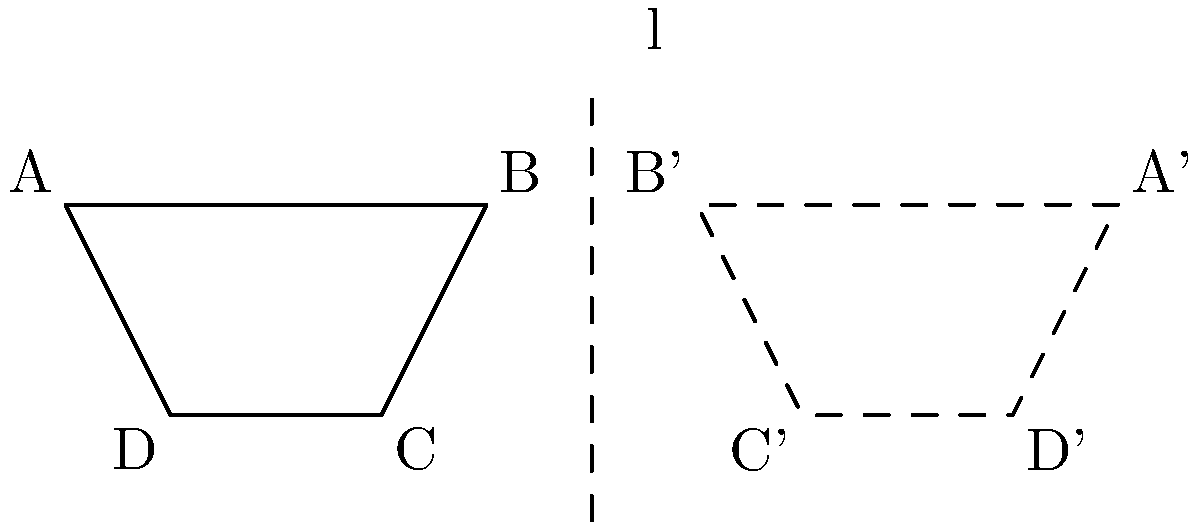Given a trapezoid ABCD and a line l, the trapezoid is reflected across line l to create A'B'C'D'. What is the distance between points B and B' in terms of the x-coordinate of point B? To solve this problem, let's follow these steps:

1) The line of reflection l is vertical and has the equation $x = 3$.

2) Point B has coordinates (2, 1).

3) When reflecting a point across a vertical line, the y-coordinate remains the same, and the x-coordinate changes.

4) The new x-coordinate of B' can be found using the formula:
   $x_{new} = 2x_{line} - x_{original}$

5) Substituting the values:
   $x_{B'} = 2(3) - 2 = 4$

6) So, B' has coordinates (4, 1).

7) The distance between B and B' is the absolute difference of their x-coordinates:
   $|x_B - x_{B'}| = |2 - 4| = 2$

8) This distance is equal to twice the difference between the x-coordinate of line l and the x-coordinate of point B:
   $2(3 - 2) = 2$

Therefore, the distance between B and B' is 2, which is twice the difference between the x-coordinate of line l (3) and the x-coordinate of point B (2).
Answer: $2(3 - x_B)$, where $x_B$ is the x-coordinate of point B 